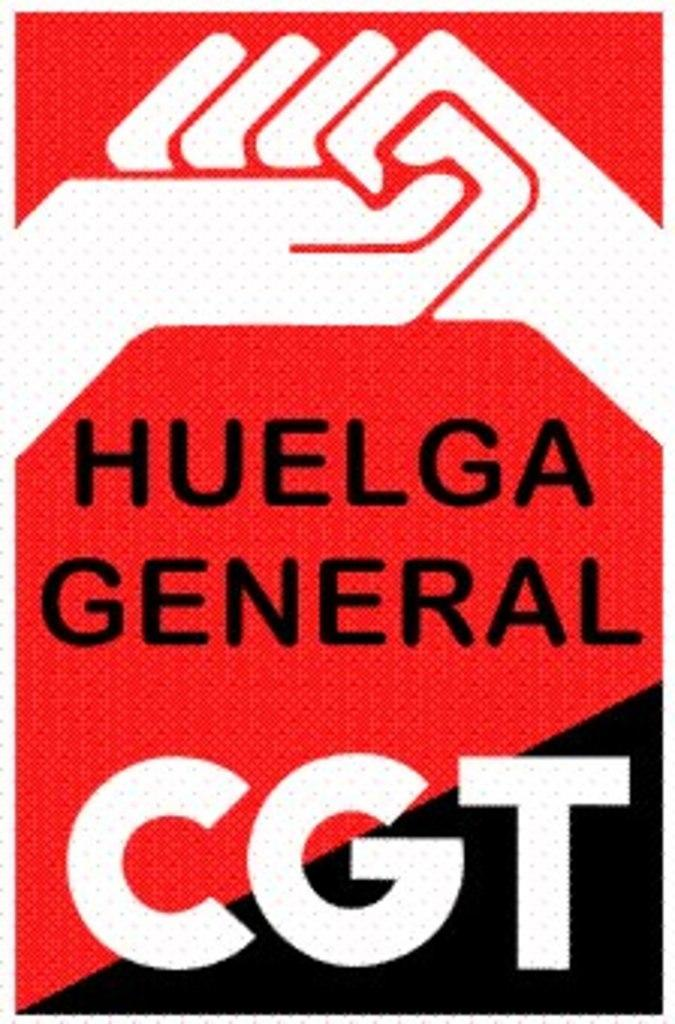<image>
Summarize the visual content of the image. A poster with two interlocking hands says Huelga General CGT. 